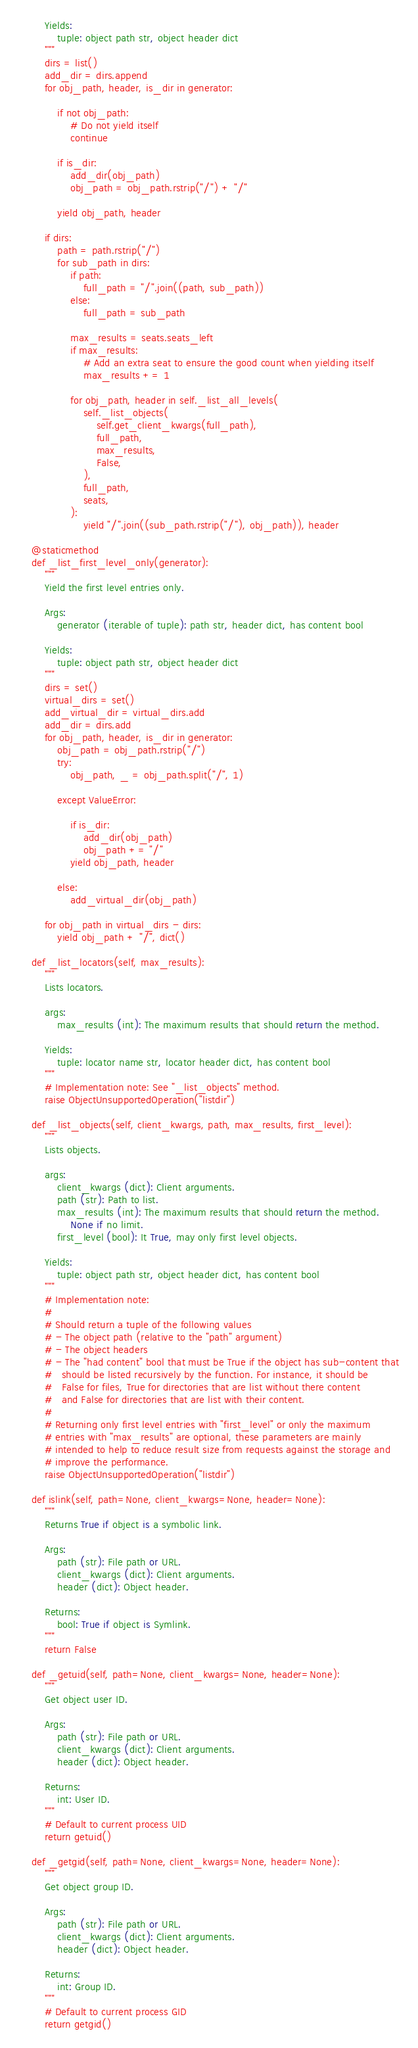<code> <loc_0><loc_0><loc_500><loc_500><_Python_>        Yields:
            tuple: object path str, object header dict
        """
        dirs = list()
        add_dir = dirs.append
        for obj_path, header, is_dir in generator:

            if not obj_path:
                # Do not yield itself
                continue

            if is_dir:
                add_dir(obj_path)
                obj_path = obj_path.rstrip("/") + "/"

            yield obj_path, header

        if dirs:
            path = path.rstrip("/")
            for sub_path in dirs:
                if path:
                    full_path = "/".join((path, sub_path))
                else:
                    full_path = sub_path

                max_results = seats.seats_left
                if max_results:
                    # Add an extra seat to ensure the good count when yielding itself
                    max_results += 1

                for obj_path, header in self._list_all_levels(
                    self._list_objects(
                        self.get_client_kwargs(full_path),
                        full_path,
                        max_results,
                        False,
                    ),
                    full_path,
                    seats,
                ):
                    yield "/".join((sub_path.rstrip("/"), obj_path)), header

    @staticmethod
    def _list_first_level_only(generator):
        """
        Yield the first level entries only.

        Args:
            generator (iterable of tuple): path str, header dict, has content bool

        Yields:
            tuple: object path str, object header dict
        """
        dirs = set()
        virtual_dirs = set()
        add_virtual_dir = virtual_dirs.add
        add_dir = dirs.add
        for obj_path, header, is_dir in generator:
            obj_path = obj_path.rstrip("/")
            try:
                obj_path, _ = obj_path.split("/", 1)

            except ValueError:

                if is_dir:
                    add_dir(obj_path)
                    obj_path += "/"
                yield obj_path, header

            else:
                add_virtual_dir(obj_path)

        for obj_path in virtual_dirs - dirs:
            yield obj_path + "/", dict()

    def _list_locators(self, max_results):
        """
        Lists locators.

        args:
            max_results (int): The maximum results that should return the method.

        Yields:
            tuple: locator name str, locator header dict, has content bool
        """
        # Implementation note: See "_list_objects" method.
        raise ObjectUnsupportedOperation("listdir")

    def _list_objects(self, client_kwargs, path, max_results, first_level):
        """
        Lists objects.

        args:
            client_kwargs (dict): Client arguments.
            path (str): Path to list.
            max_results (int): The maximum results that should return the method.
                None if no limit.
            first_level (bool): It True, may only first level objects.

        Yields:
            tuple: object path str, object header dict, has content bool
        """
        # Implementation note:
        #
        # Should return a tuple of the following values
        # - The object path (relative to the "path" argument)
        # - The object headers
        # - The "had content" bool that must be True if the object has sub-content that
        #   should be listed recursively by the function. For instance, it should be
        #   False for files, True for directories that are list without there content
        #   and False for directories that are list with their content.
        #
        # Returning only first level entries with "first_level" or only the maximum
        # entries with "max_results" are optional, these parameters are mainly
        # intended to help to reduce result size from requests against the storage and
        # improve the performance.
        raise ObjectUnsupportedOperation("listdir")

    def islink(self, path=None, client_kwargs=None, header=None):
        """
        Returns True if object is a symbolic link.

        Args:
            path (str): File path or URL.
            client_kwargs (dict): Client arguments.
            header (dict): Object header.

        Returns:
            bool: True if object is Symlink.
        """
        return False

    def _getuid(self, path=None, client_kwargs=None, header=None):
        """
        Get object user ID.

        Args:
            path (str): File path or URL.
            client_kwargs (dict): Client arguments.
            header (dict): Object header.

        Returns:
            int: User ID.
        """
        # Default to current process UID
        return getuid()

    def _getgid(self, path=None, client_kwargs=None, header=None):
        """
        Get object group ID.

        Args:
            path (str): File path or URL.
            client_kwargs (dict): Client arguments.
            header (dict): Object header.

        Returns:
            int: Group ID.
        """
        # Default to current process GID
        return getgid()
</code> 